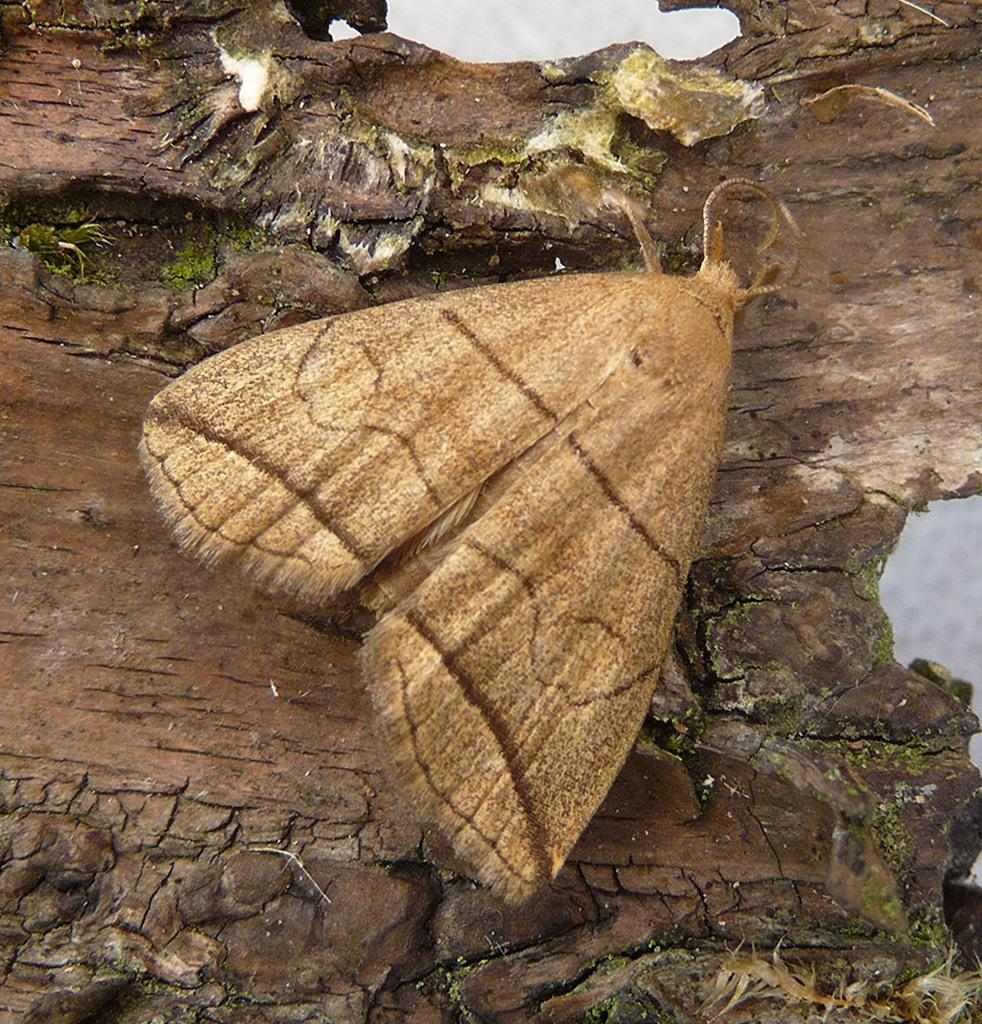What is present in the image? There is a fly in the image. Where is the fly located? The fly is on the bark of a tree. What type of tent can be seen in the image? There is no tent present in the image; it only features a fly on the bark of a tree. 